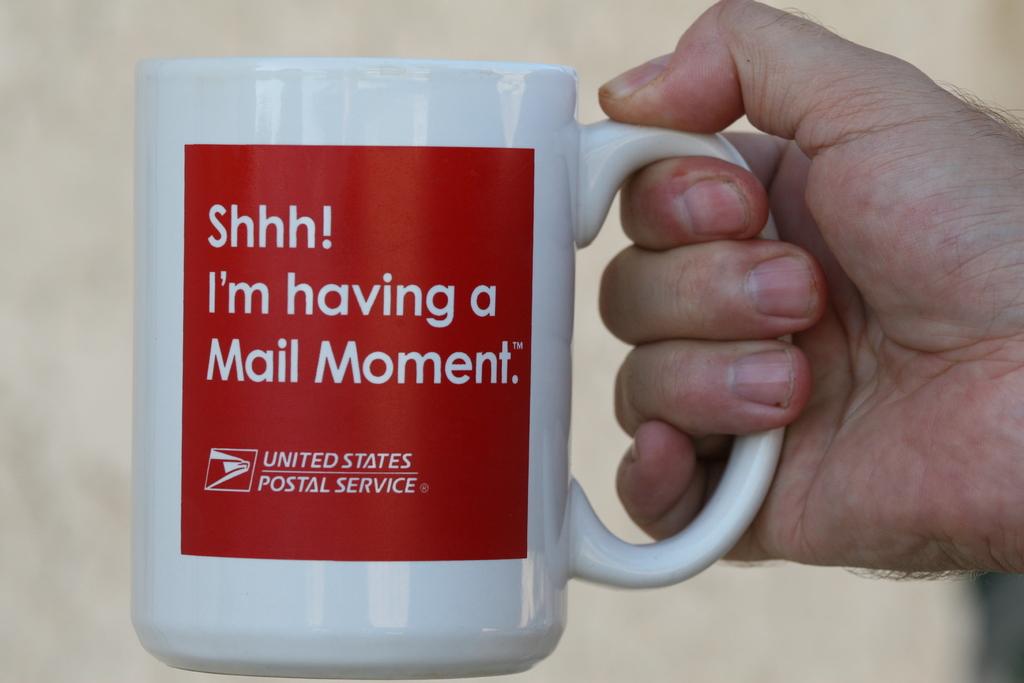What postal service is this for?
Offer a very short reply. United states. What kind of moment?
Offer a terse response. Mail. 